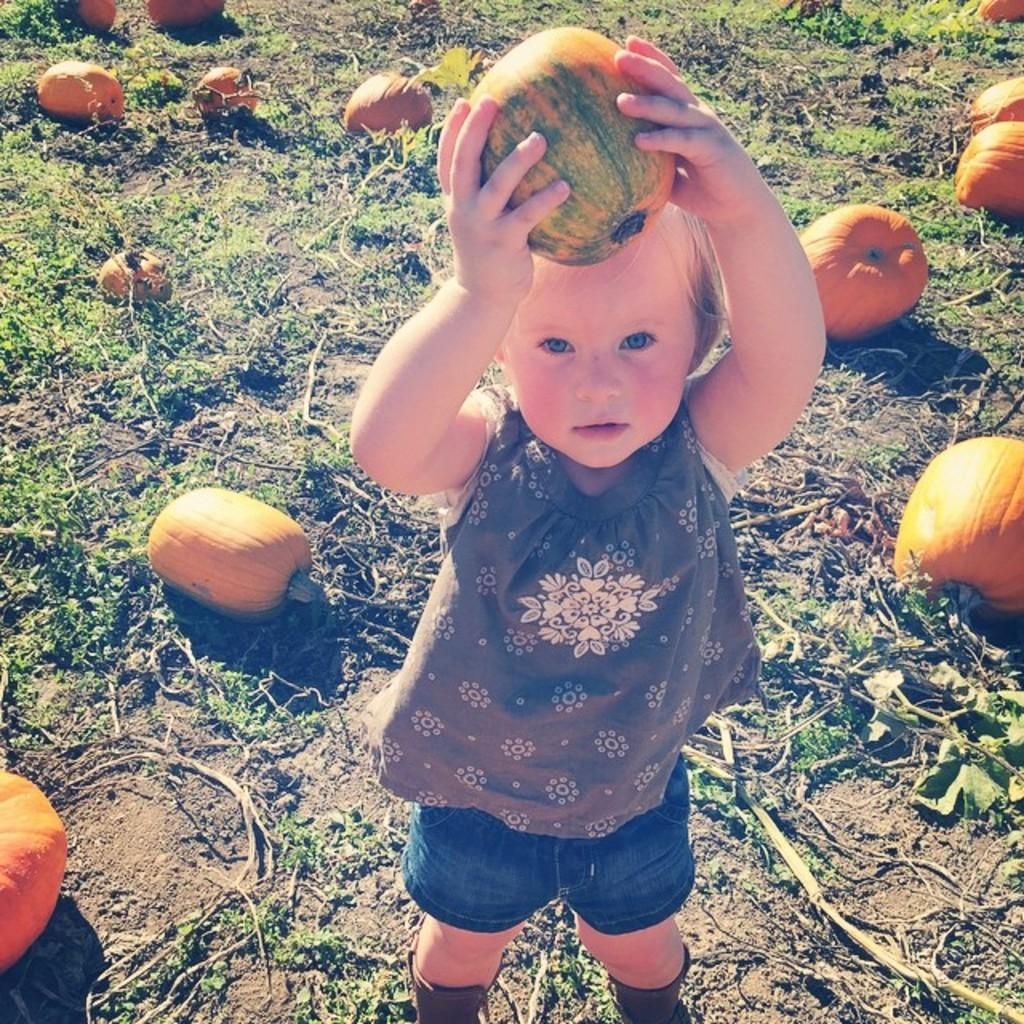Who is the main subject in the picture? There is a girl in the picture. What is the girl holding in the image? The girl is standing and holding a pumpkin. What else can be seen on the ground in the image? There are pumpkins on the ground. What type of vegetation is visible in the image? There are plants visible in the image. What is the owner of the pumpkins doing in the image? There is no indication of an owner in the image, as it only features a girl holding a pumpkin and other pumpkins on the ground. --- Facts: 1. There is a car in the image. 2. The car is parked on the street. 3. There are trees on both sides of the street. 4. The sky is visible in the image. Absurd Topics: dance, ocean, guitar Conversation: What is the main subject in the image? There is a car in the image. Where is the car located in the image? The car is parked on the street. What can be seen on both sides of the street in the image? There are trees on both sides of the street. What is visible in the background of the image? The sky is visible in the image. Reasoning: Let's think step by step in order to produce the conversation. We start by identifying the main subject in the image, which is the car. Then, we expand the conversation to include where the car is located (on the street) and what can be seen on both sides of the street (trees). Finally, we mention the presence of the sky in the image to give a sense of the setting. Absurd Question/Answer: What type of dance is being performed in the image? There is no dance or dancer present in the image; it features a parked car on the street with trees on both sides and the sky visible in the background. 